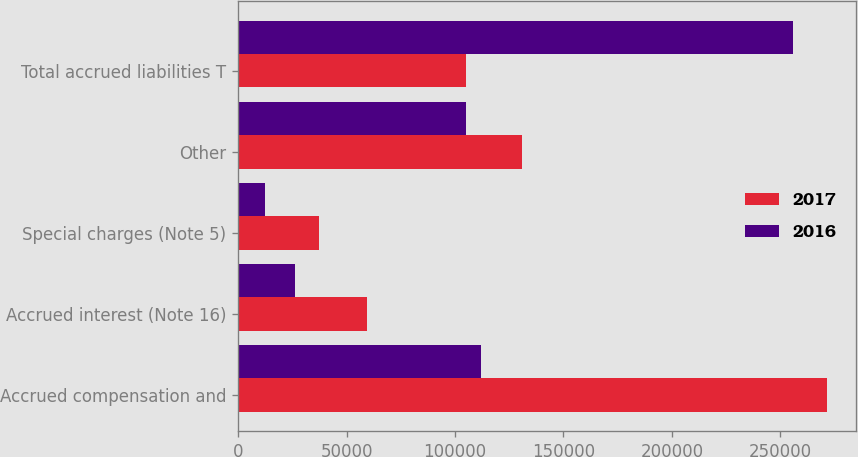Convert chart. <chart><loc_0><loc_0><loc_500><loc_500><stacked_bar_chart><ecel><fcel>Accrued compensation and<fcel>Accrued interest (Note 16)<fcel>Special charges (Note 5)<fcel>Other<fcel>Total accrued liabilities T<nl><fcel>2017<fcel>271321<fcel>59400<fcel>37348<fcel>130757<fcel>105069<nl><fcel>2016<fcel>112003<fcel>26411<fcel>12374<fcel>105069<fcel>255857<nl></chart> 